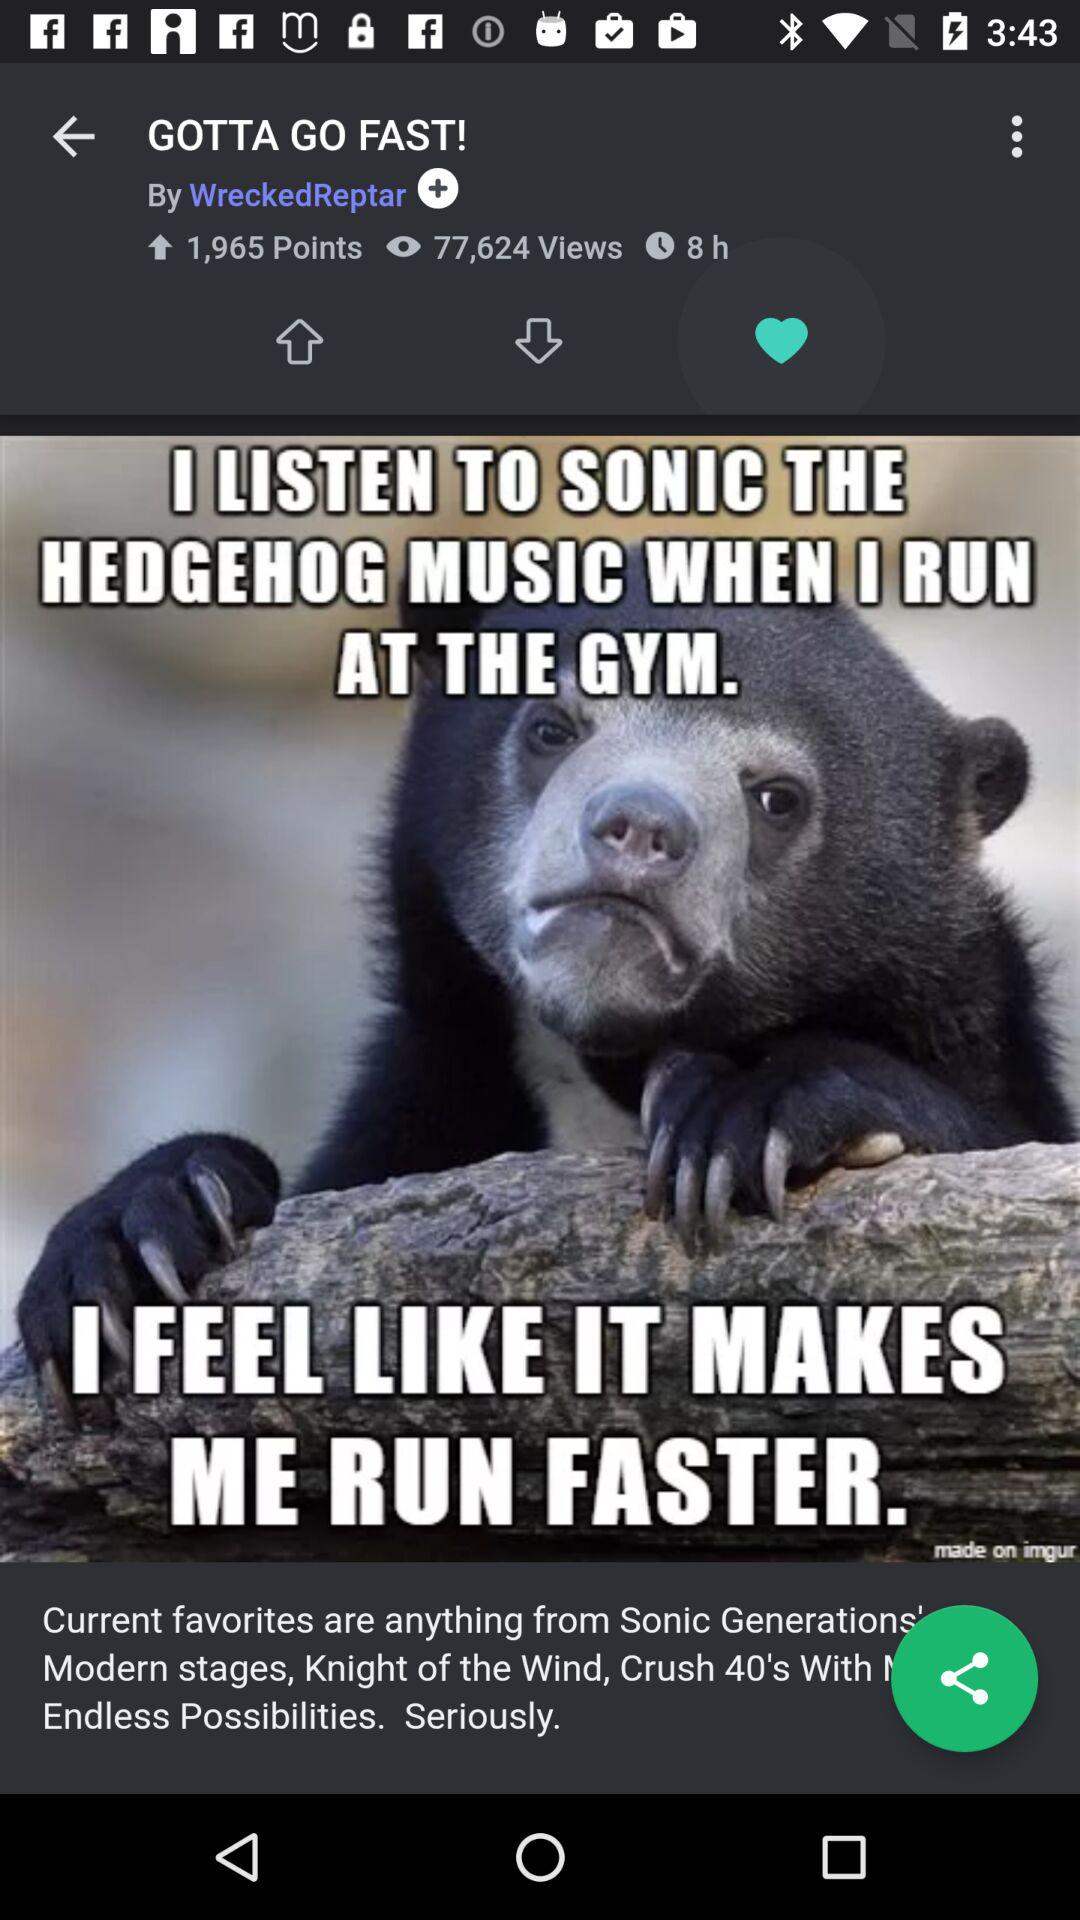How long ago was the picture posted? The picture was posted 8 hours ago. 